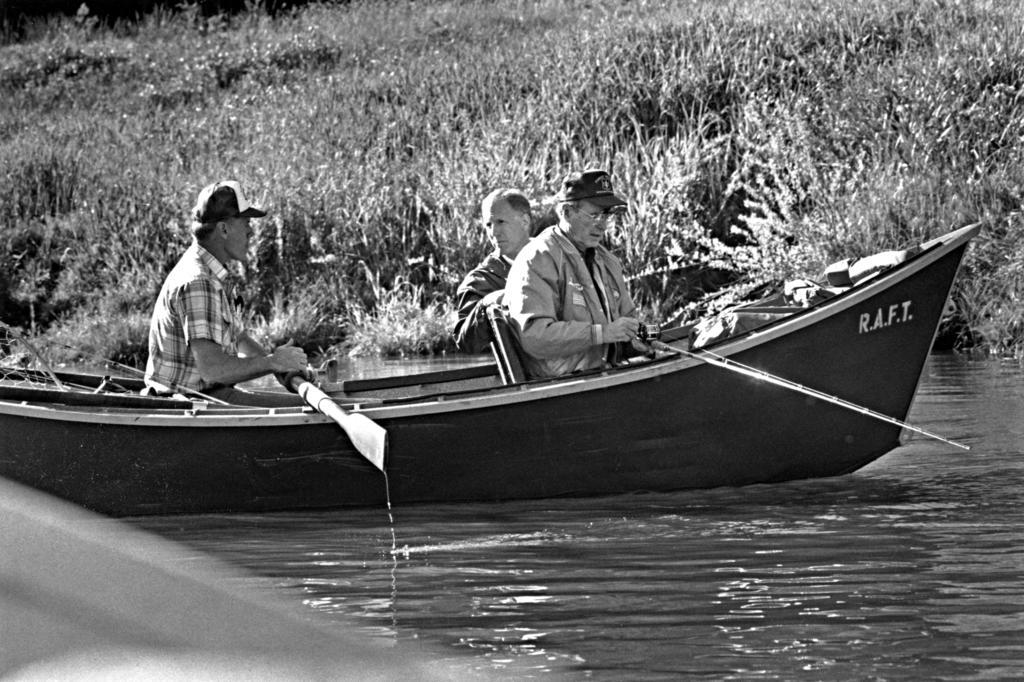How many people are in the image? There are three persons in the image. What are the persons doing in the image? The persons are sailing a boat. What can be seen below the boat in the image? There is a water surface visible in the image. What type of vegetation is visible in the background of the image? There are plants in the background of the image. What is the color of the belief in the image? There is no mention of a belief in the image, so it is not possible to determine its color. 